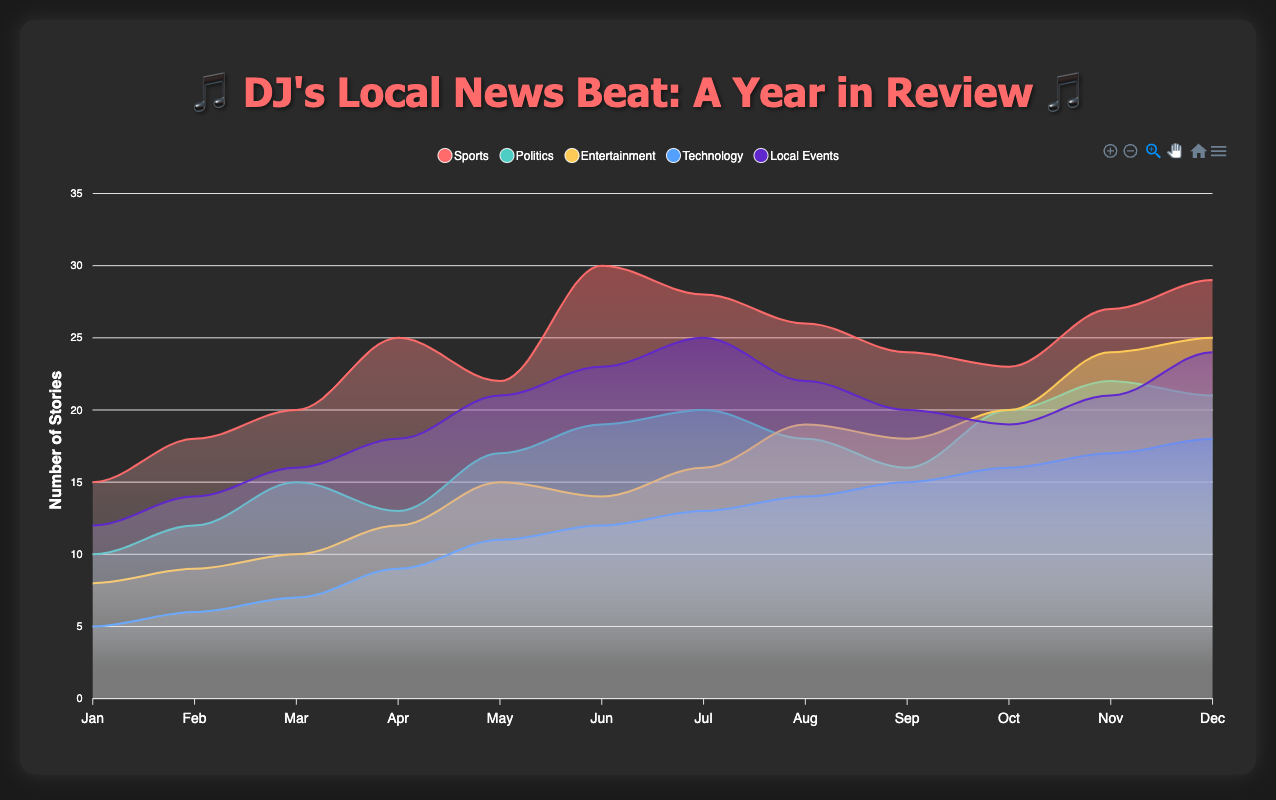What's the most common category of news coverage in July? To determine this, locate the series of data for July and identify the highest value. Sports has the highest value in July with 28 stories.
Answer: Sports Which category saw the highest peak in news coverage throughout the year? Review each category's data to find the highest single value. Sports peaks at 30 stories in June, higher than any other category's peak.
Answer: Sports How many months did Politics have less coverage than Entertainment? Compare Politics and Entertainment values for each month. Politics has fewer stories than Entertainment in March, April, May, and August, totaling 4 months.
Answer: 4 months What's the average number of Technology stories per month? Sum all Technology values and divide by 12 months. (5 + 6 + 7 + 9 + 11 + 12 + 13 + 14 + 15 + 16 + 17 + 18) / 12 = 11.5
Answer: 11.5 In which month did Local Events have its maximum coverage, and how many stories were there? Look for the highest value in Local Events series. Local Events peaked in June with 25 stories.
Answer: June, 25 stories How does the total number of Sports stories in the second half of the year compare to the first half? Sum Sports values for January to June and July to December. First half: 15 + 18 + 20 + 25 + 22 + 30 = 130. Second half: 28 + 26 + 24 + 23 + 27 + 29 = 157. Second half has 27 more stories.
Answer: Second half has 27 more stories What's the combined number of stories for Technology from March to May? Add Technology values for March, April, and May. 7 + 9 + 11 = 27
Answer: 27 Which category had the least coverage in December? Compare all categories' values in December. Technology has the least with 18 stories.
Answer: Technology Did any category consistently increase its number of stories every month? Check each category to see if values consistently rise each month. None of the categories show a consistent month-to-month increase.
Answer: None 